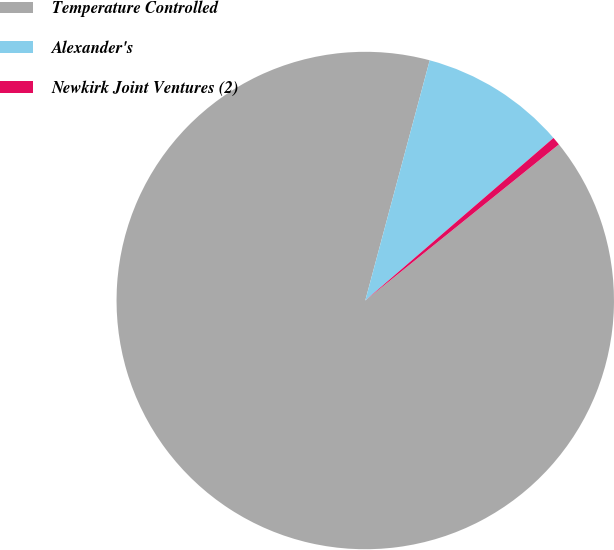<chart> <loc_0><loc_0><loc_500><loc_500><pie_chart><fcel>Temperature Controlled<fcel>Alexander's<fcel>Newkirk Joint Ventures (2)<nl><fcel>89.97%<fcel>9.49%<fcel>0.54%<nl></chart> 